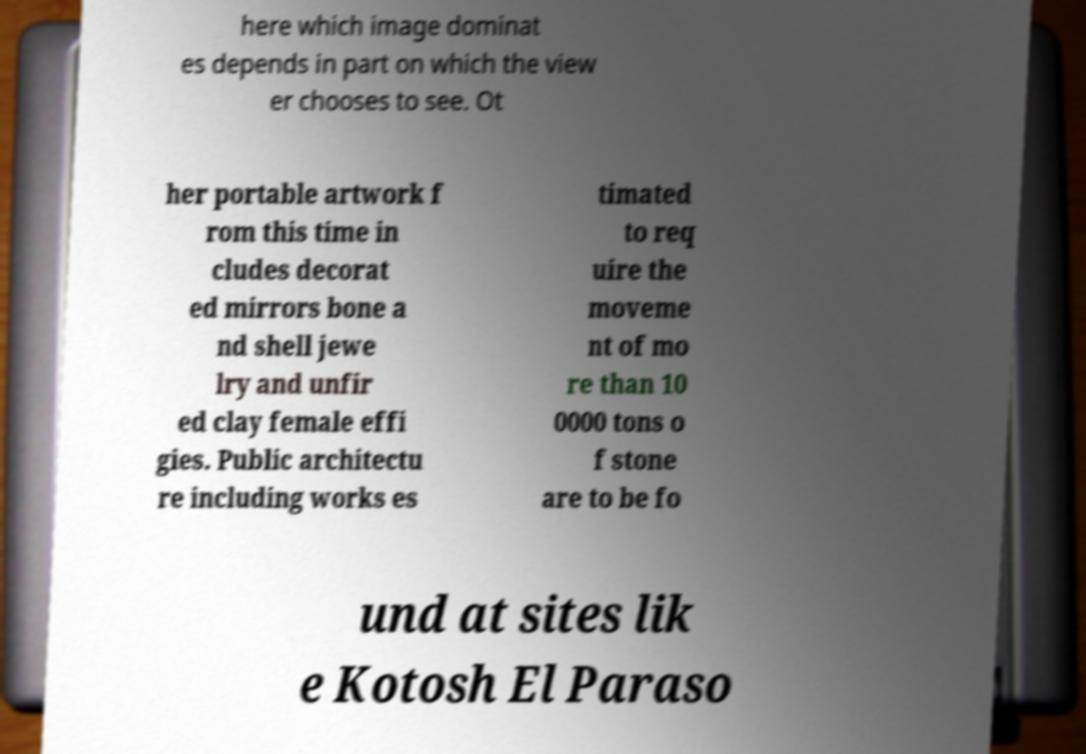What messages or text are displayed in this image? I need them in a readable, typed format. here which image dominat es depends in part on which the view er chooses to see. Ot her portable artwork f rom this time in cludes decorat ed mirrors bone a nd shell jewe lry and unfir ed clay female effi gies. Public architectu re including works es timated to req uire the moveme nt of mo re than 10 0000 tons o f stone are to be fo und at sites lik e Kotosh El Paraso 